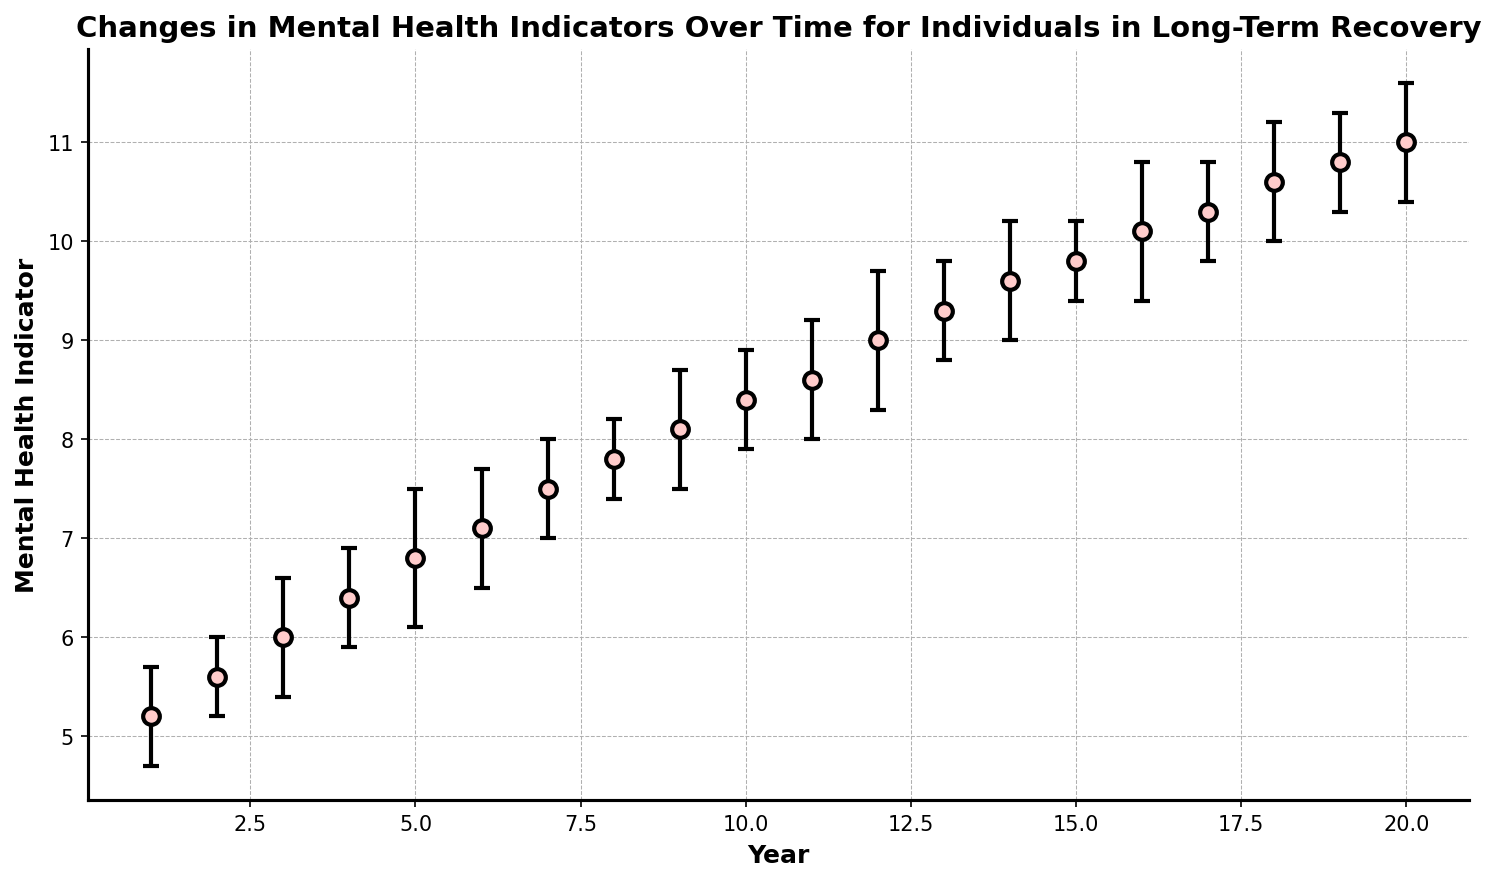What is the general trend of the mental health indicator over the years? The chart shows a general upward trend in the mental health indicator from Year 1 to Year 20. Each year, the value increases along with error bars indicating variability.
Answer: Increasing What is the highest value of the mental health indicator, and in which year does it occur? The highest value of the mental health indicator is 11.0, which occurs in Year 20 according to the chart.
Answer: 11.0, Year 20 Between which two years does the mental health indicator have the largest increase? To determine this, look at the differences between consecutive years. The largest increase occurs between Year 19 (10.8) and Year 20 (11.0), which is 0.2.
Answer: Year 19 to Year 20 How does the mental health indicator in Year 10 compare to that in Year 5? In Year 10, the indicator is 8.4, whereas in Year 5, it is 6.8. Therefore, the indicator in Year 10 is higher.
Answer: Higher in Year 10 What are the error bars' ranges for Year 8 and Year 12, and how do they compare? The error bar range for Year 8 is 7.8 ± 0.4 (7.4 to 8.2), and for Year 12 it is 9.0 ± 0.7 (8.3 to 9.7). The error bar range for Year 12 is wider compared to Year 8.
Answer: Year 12 has a wider range What is the average value of the mental health indicator over the first 5 years? The values for the first 5 years are 5.2, 5.6, 6.0, 6.4, and 6.8. The average is (5.2 + 5.6 + 6.0 + 6.4 + 6.8) / 5 = 6.0.
Answer: 6.0 Between Years 8 and 10, does the mental health indicator show steady growth, and by how much? In Year 8, the indicator is 7.8; in Year 9, it is 8.1; and in Year 10, it is 8.4. The increases are 0.3 per year, showing steady growth.
Answer: Yes, 0.3 per year What visual elements are used to indicate the variability of the data points? The chart uses error bars to show the variability in the data points, indicated by vertical lines with caps extending above and below each data point.
Answer: Error bars What is the difference in the mental health indicator between Years 15 and 18? In Year 15, the indicator is 9.8, and in Year 18 it is 10.6. The difference is 10.6 - 9.8 = 0.8.
Answer: 0.8 How does the error bar for Year 2 compare to that of Year 7? The error bar for Year 2 is 0.4, whereas for Year 7 it is 0.5. Therefore, the error bar in Year 7 is slightly larger.
Answer: Year 7 is larger 